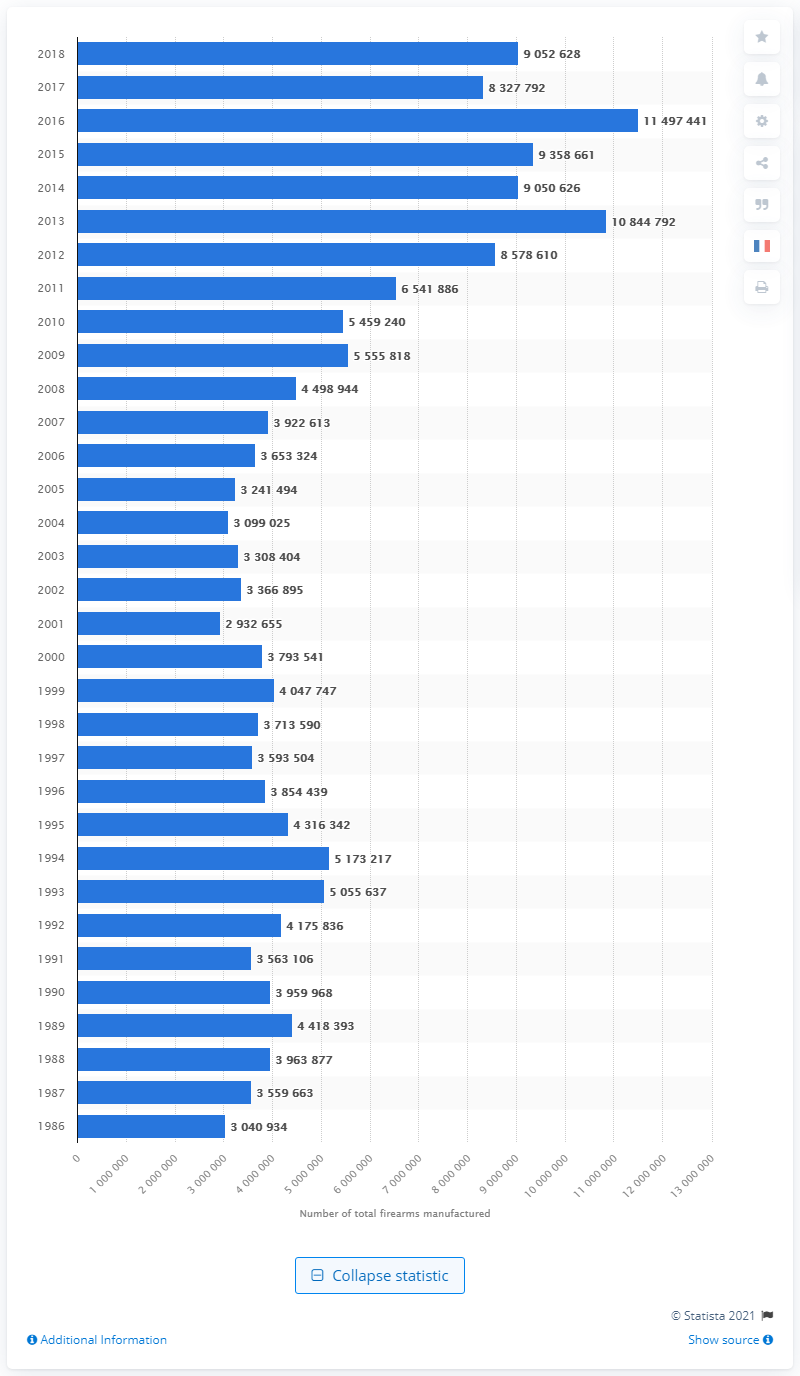Draw attention to some important aspects in this diagram. In 2018, a total of 90,526,281 firearms were manufactured in the United States. 